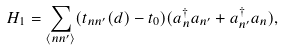Convert formula to latex. <formula><loc_0><loc_0><loc_500><loc_500>H _ { 1 } = \sum _ { \langle n n ^ { \prime } \rangle } ( t _ { n n ^ { \prime } } ( { d } ) - t _ { 0 } ) ( a ^ { \dag } _ { n } a _ { n ^ { \prime } } + a ^ { \dag } _ { n ^ { \prime } } a _ { n } ) ,</formula> 